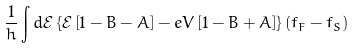<formula> <loc_0><loc_0><loc_500><loc_500>\frac { 1 } { h } \int d { \mathcal { E } } \left \{ { \mathcal { E } } \left [ 1 - B - A \right ] - e V \left [ 1 - B + A \right ] \right \} \left ( f _ { F } - f _ { S } \right )</formula> 